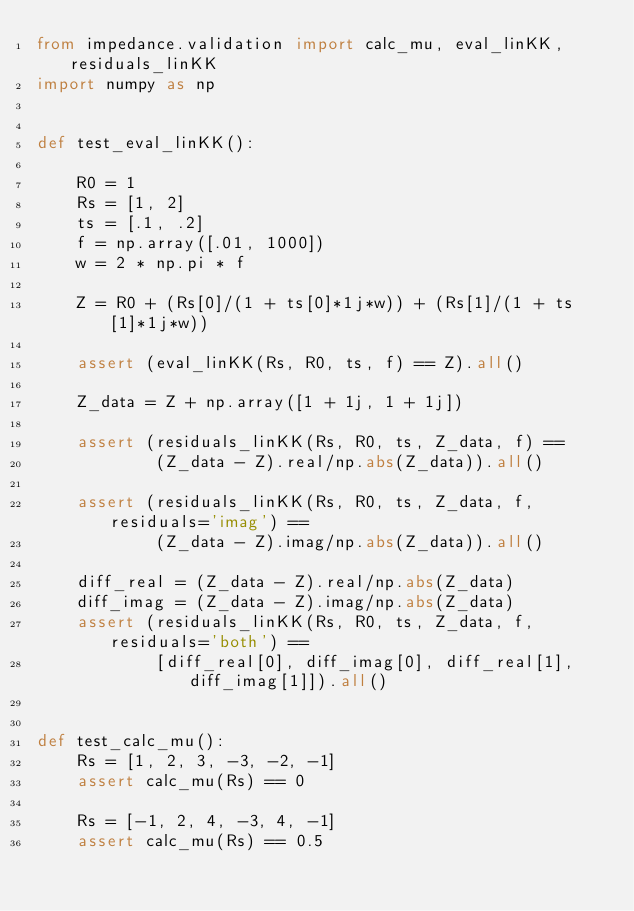<code> <loc_0><loc_0><loc_500><loc_500><_Python_>from impedance.validation import calc_mu, eval_linKK, residuals_linKK
import numpy as np


def test_eval_linKK():

    R0 = 1
    Rs = [1, 2]
    ts = [.1, .2]
    f = np.array([.01, 1000])
    w = 2 * np.pi * f

    Z = R0 + (Rs[0]/(1 + ts[0]*1j*w)) + (Rs[1]/(1 + ts[1]*1j*w))

    assert (eval_linKK(Rs, R0, ts, f) == Z).all()

    Z_data = Z + np.array([1 + 1j, 1 + 1j])

    assert (residuals_linKK(Rs, R0, ts, Z_data, f) ==
            (Z_data - Z).real/np.abs(Z_data)).all()

    assert (residuals_linKK(Rs, R0, ts, Z_data, f, residuals='imag') ==
            (Z_data - Z).imag/np.abs(Z_data)).all()

    diff_real = (Z_data - Z).real/np.abs(Z_data)
    diff_imag = (Z_data - Z).imag/np.abs(Z_data)
    assert (residuals_linKK(Rs, R0, ts, Z_data, f, residuals='both') ==
            [diff_real[0], diff_imag[0], diff_real[1], diff_imag[1]]).all()


def test_calc_mu():
    Rs = [1, 2, 3, -3, -2, -1]
    assert calc_mu(Rs) == 0

    Rs = [-1, 2, 4, -3, 4, -1]
    assert calc_mu(Rs) == 0.5
</code> 